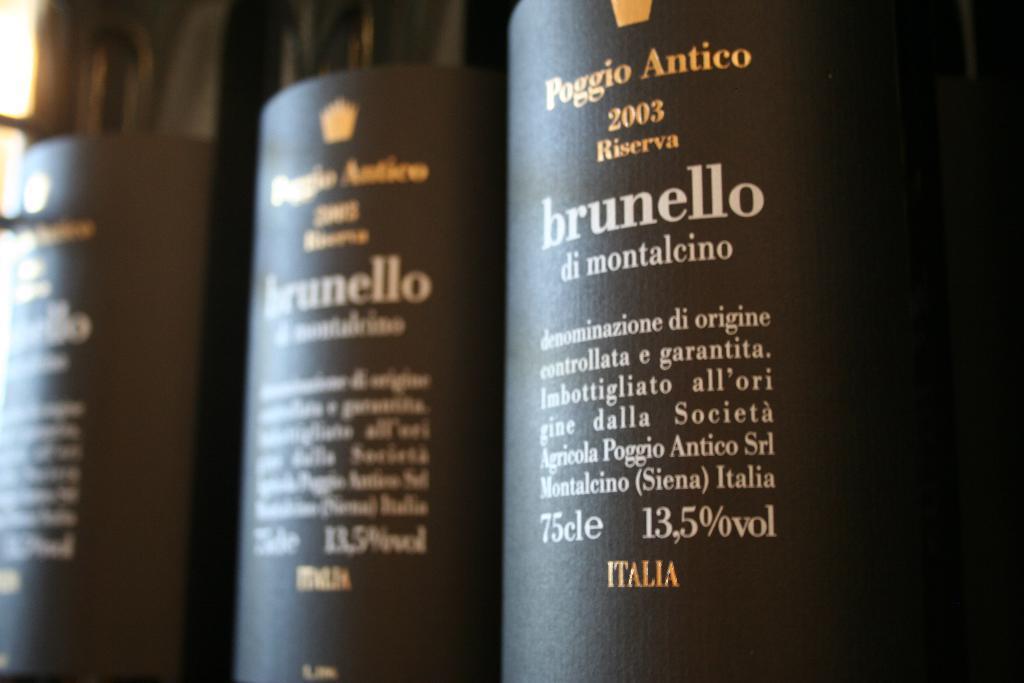Describe this image in one or two sentences. In this picture we can see three bottles with stickers on it. 